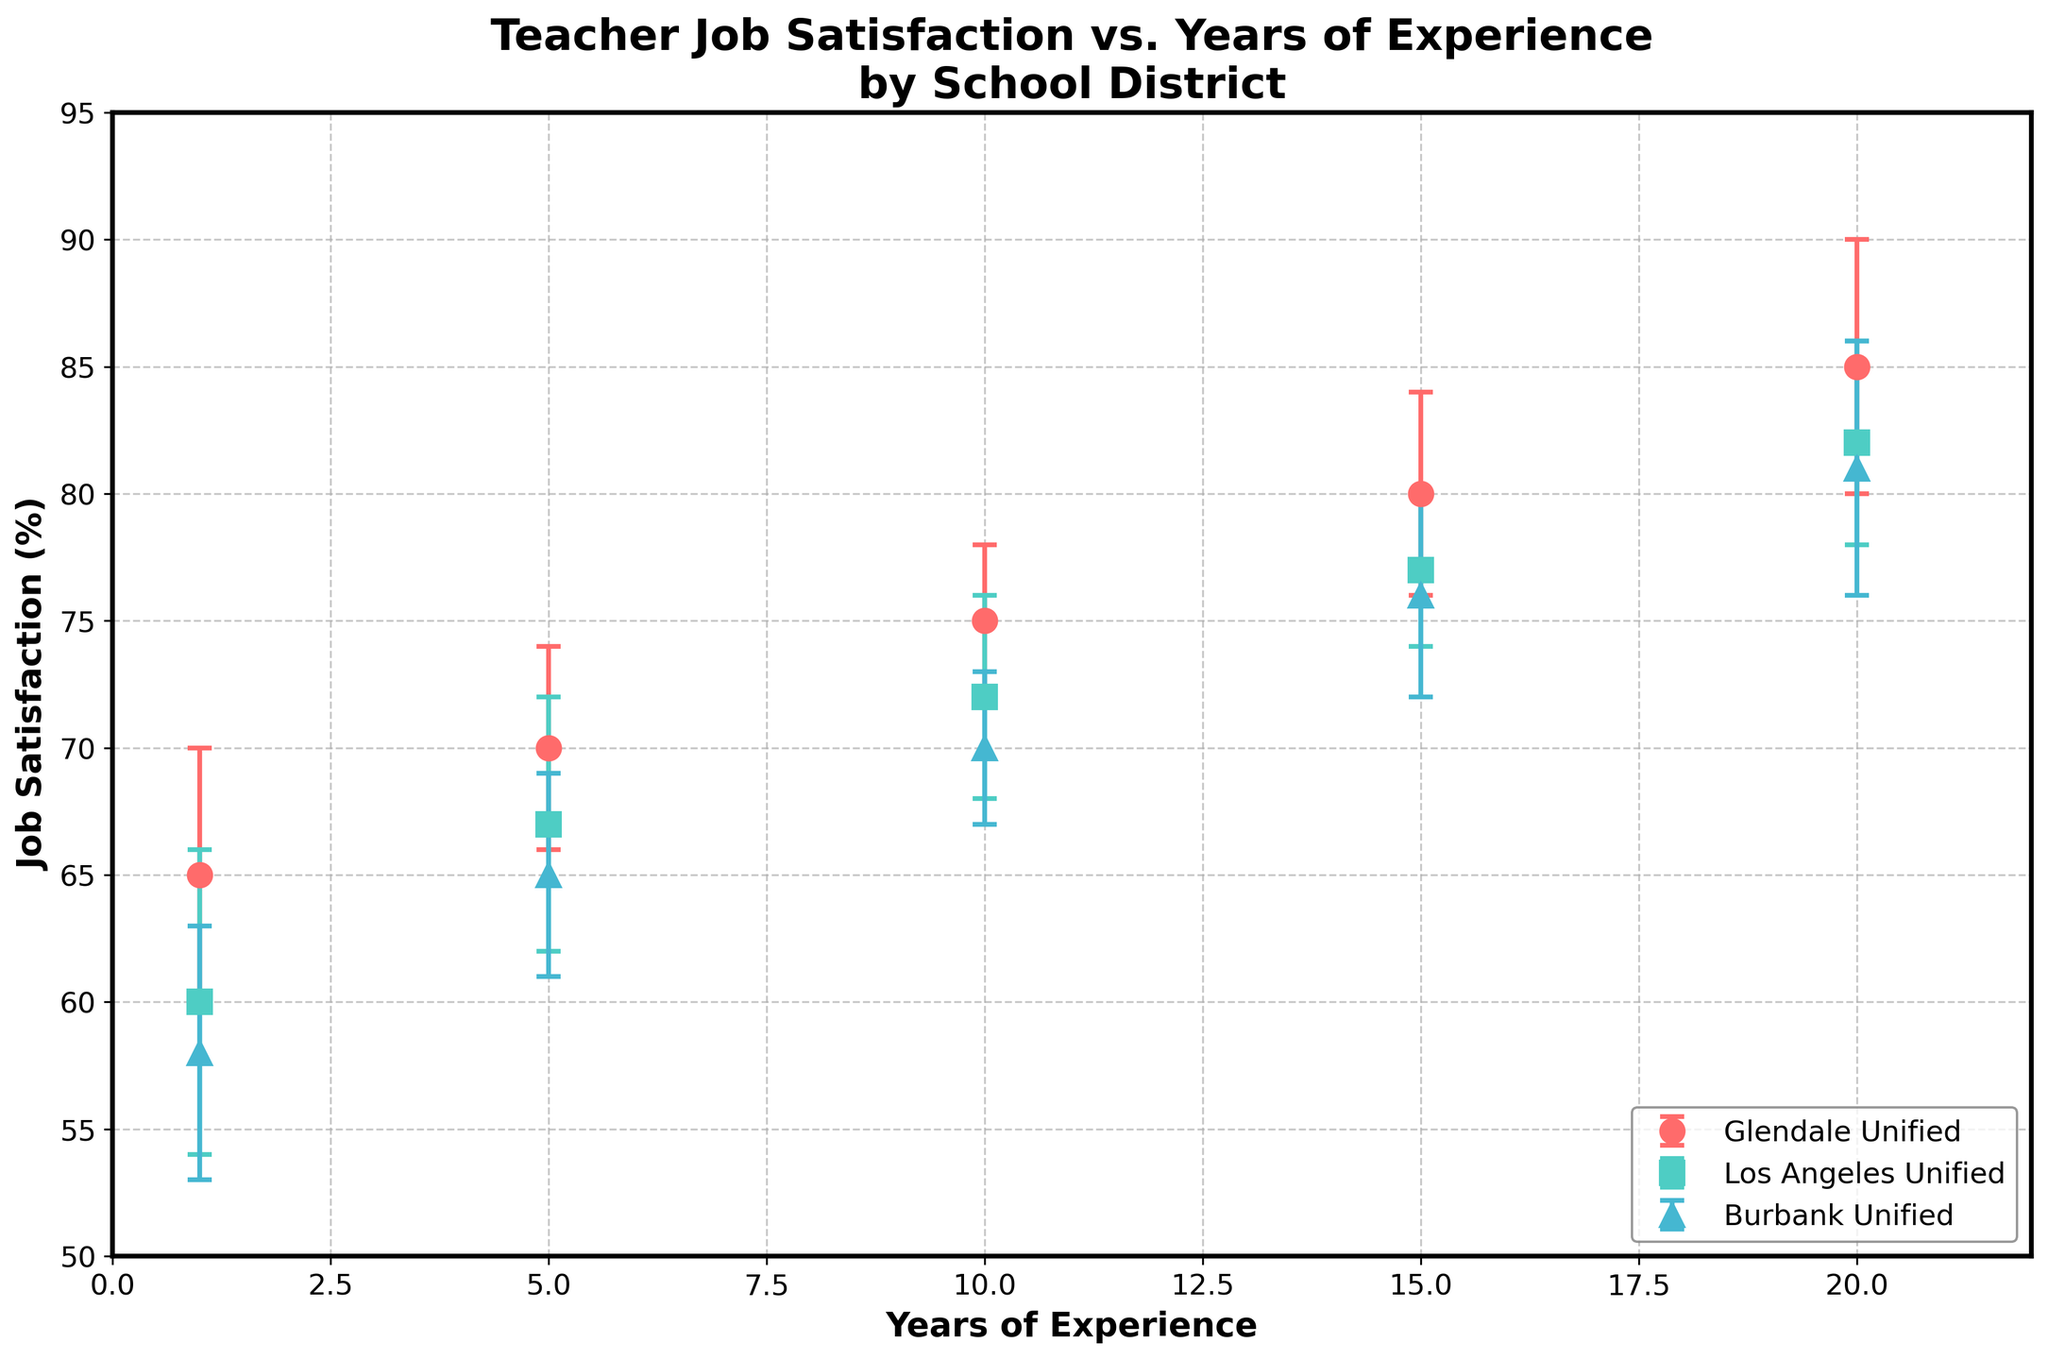What is the title of the figure? The title of the figure is found at the top of the plot, indicating what the figure is about.
Answer: Teacher Job Satisfaction vs. Years of Experience by School District How many school districts are represented in the figure? To determine the number of school districts, look for the distinct labels in the legend of the plot.
Answer: 3 Which school district has the highest job satisfaction for teachers with 20 years of experience? Identify the data points for 20 years of experience across all school districts, then compare their job satisfaction values. Glendale Unified has 85%, Los Angeles Unified has 82%, and Burbank Unified has 81%. Glendale Unified has the highest value.
Answer: Glendale Unified What is the job satisfaction for Los Angeles Unified teachers with 5 years of experience? Locate the data point corresponding to 5 years of experience for Los Angeles Unified and read the job satisfaction value from the graph.
Answer: 67 Which district has the largest difference in job satisfaction between 1 year and 5 years of experience? For each district, subtract the job satisfaction value at 1 year from the value at 5 years, then compare the differences. Glendale Unified has a difference of 70 - 65 = 5, Los Angeles Unified has 67 - 60 = 7, and Burbank Unified has 65 - 58 = 7. Both Los Angeles Unified and Burbank Unified have the largest difference of 7.
Answer: Los Angeles Unified and Burbank Unified Considering error bars, which district shows the greatest variability in job satisfaction for teachers with 1 year of experience? The variability is indicated by the length of the error bars. Compare the lengths for the 1-year experience data points for each district. Glendale Unified has an error of 5, Los Angeles Unified has 6, and Burbank Unified has 5. Los Angeles Unified has the greatest variability.
Answer: Los Angeles Unified What is the general trend of job satisfaction across all districts as years of experience increase? Observe the pattern of data points and error bars for all districts as the years of experience go from 1 to 20. All districts show an increasing trend in job satisfaction with more years of experience.
Answer: Increasing How does job satisfaction compare between Glendale Unified and Burbank Unified at 10 years of experience? Compare the data points for 10 years of experience in both Glendale Unified and Burbank Unified. Glendale Unified has a job satisfaction of 75 and Burbank Unified has 70. Glendale Unified has higher job satisfaction.
Answer: Glendale Unified Calculate the average job satisfaction for Glendale Unified teachers from 1 to 20 years of experience. Add the job satisfaction values for Glendale Unified at 1, 5, 10, 15, and 20 years and then divide by the number of data points: (65 + 70 + 75 + 80 + 85) / 5. The average is (375) / 5 = 75.
Answer: 75 